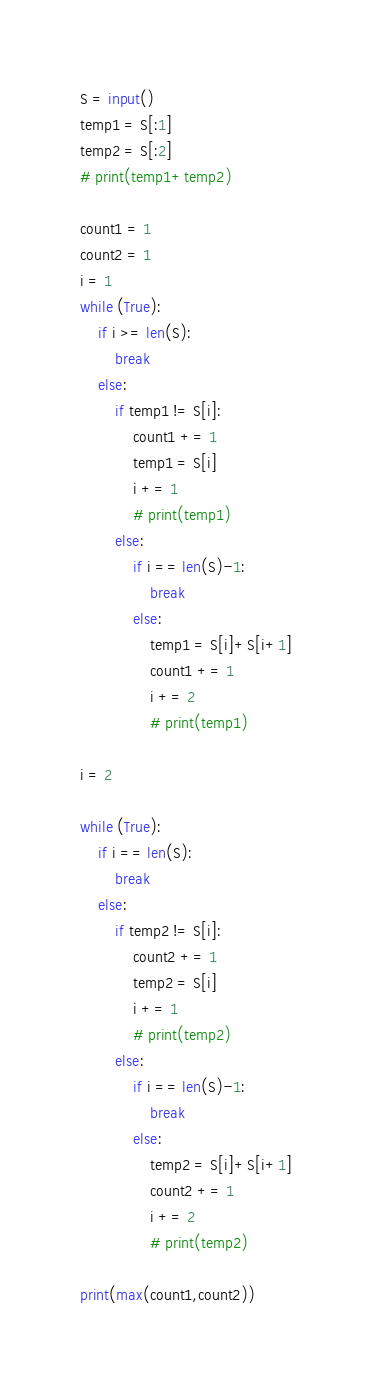<code> <loc_0><loc_0><loc_500><loc_500><_Python_>S = input()
temp1 = S[:1]
temp2 = S[:2]
# print(temp1+temp2)

count1 = 1
count2 = 1
i = 1
while (True):
    if i >= len(S):
        break
    else:
        if temp1 != S[i]:
            count1 += 1
            temp1 = S[i]
            i += 1
            # print(temp1)
        else:
            if i == len(S)-1:
                break
            else:
                temp1 = S[i]+S[i+1]
                count1 += 1
                i += 2
                # print(temp1)

i = 2

while (True):
    if i == len(S):
        break
    else:
        if temp2 != S[i]:
            count2 += 1
            temp2 = S[i]
            i += 1
            # print(temp2)
        else:
            if i == len(S)-1:
                break
            else:
                temp2 = S[i]+S[i+1]
                count2 += 1
                i += 2
                # print(temp2)

print(max(count1,count2))</code> 